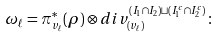<formula> <loc_0><loc_0><loc_500><loc_500>\omega _ { \ell } = \pi _ { v _ { \ell } } ^ { * } ( \rho ) \otimes d i v ^ { ( I _ { 1 } \cap I _ { 2 } ) \sqcup ( I _ { 1 } ^ { c } \cap I _ { 2 } ^ { c } ) } _ { ( v _ { \ell } ) } \colon</formula> 